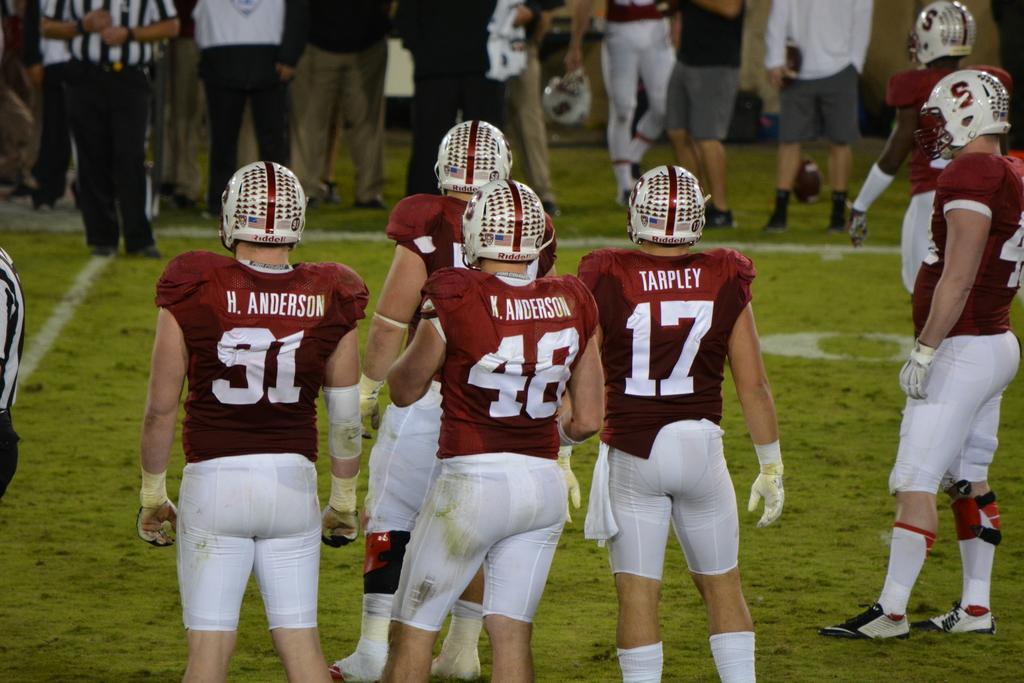In one or two sentences, can you explain what this image depicts? In this image on the right, there is a man, he wears a t shirt, trouser, shoes and helmet. In the middle there is a man, he wears a t shirt, trouser, helmet and there is a man, he wears a t shirt, trouser, helmet, in front of him there is a man, he wears a t shirt, trouser, helmet. On the left there is a man, he wears a t shirt, trouser, helmet. At the top there are many people. At the bottom there is a grass. 